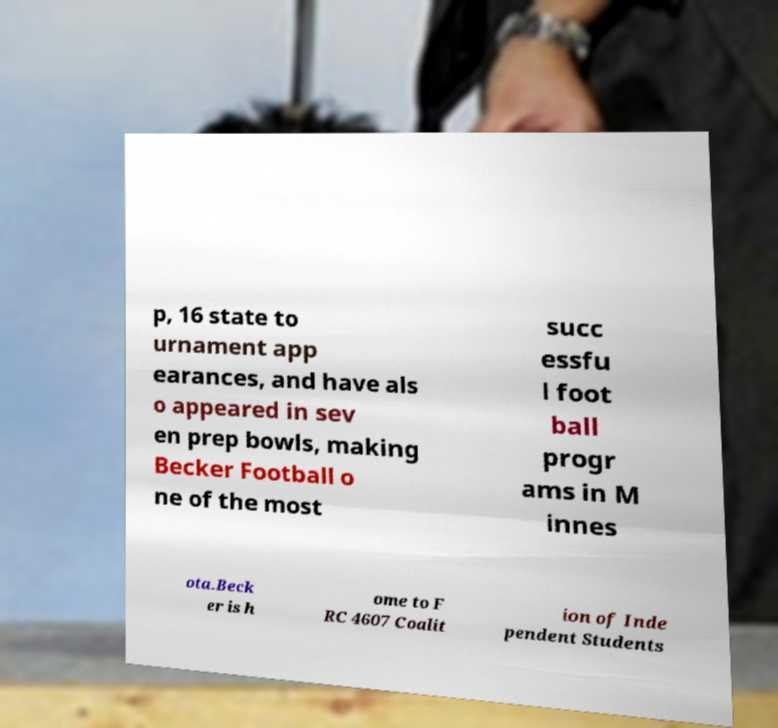I need the written content from this picture converted into text. Can you do that? p, 16 state to urnament app earances, and have als o appeared in sev en prep bowls, making Becker Football o ne of the most succ essfu l foot ball progr ams in M innes ota.Beck er is h ome to F RC 4607 Coalit ion of Inde pendent Students 